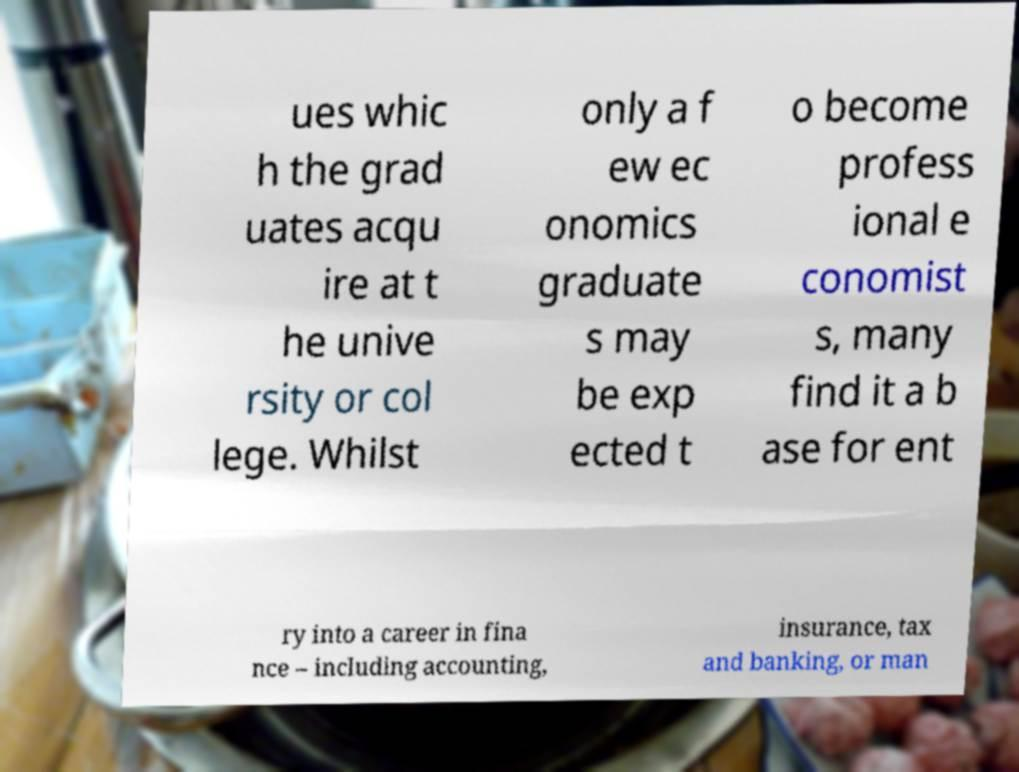I need the written content from this picture converted into text. Can you do that? ues whic h the grad uates acqu ire at t he unive rsity or col lege. Whilst only a f ew ec onomics graduate s may be exp ected t o become profess ional e conomist s, many find it a b ase for ent ry into a career in fina nce – including accounting, insurance, tax and banking, or man 